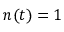Convert formula to latex. <formula><loc_0><loc_0><loc_500><loc_500>n ( t ) = 1</formula> 